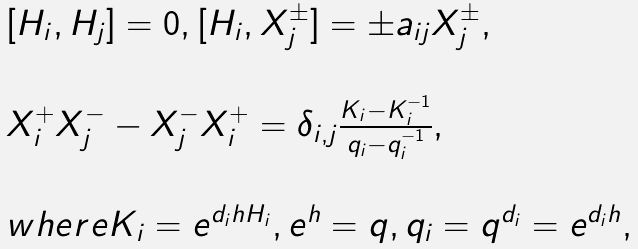Convert formula to latex. <formula><loc_0><loc_0><loc_500><loc_500>\begin{array} { l } [ H _ { i } , H _ { j } ] = 0 , [ H _ { i } , X _ { j } ^ { \pm } ] = \pm a _ { i j } X _ { j } ^ { \pm } , \\ \\ X _ { i } ^ { + } X _ { j } ^ { - } - X _ { j } ^ { - } X _ { i } ^ { + } = \delta _ { i , j } \frac { K _ { i } - K _ { i } ^ { - 1 } } { q _ { i } - q _ { i } ^ { - 1 } } , \\ \\ w h e r e K _ { i } = e ^ { d _ { i } h H _ { i } } , e ^ { h } = q , q _ { i } = q ^ { d _ { i } } = e ^ { d _ { i } h } , \end{array}</formula> 